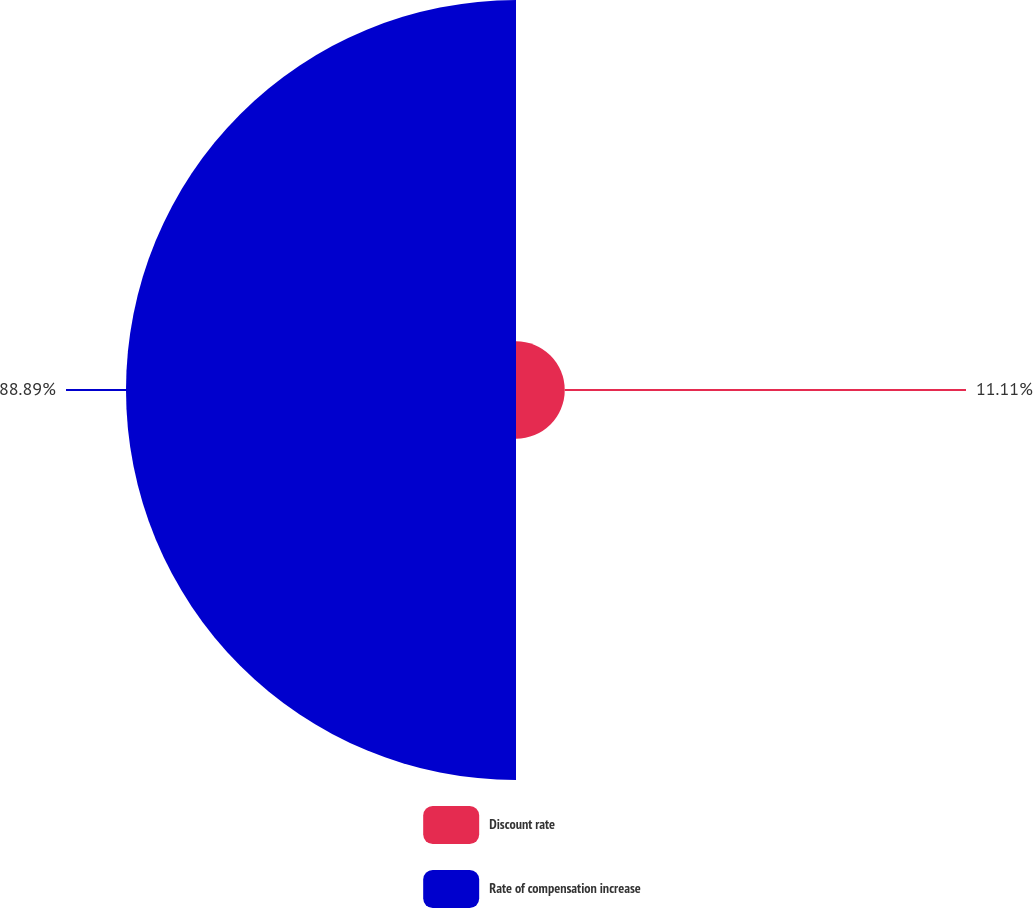<chart> <loc_0><loc_0><loc_500><loc_500><pie_chart><fcel>Discount rate<fcel>Rate of compensation increase<nl><fcel>11.11%<fcel>88.89%<nl></chart> 